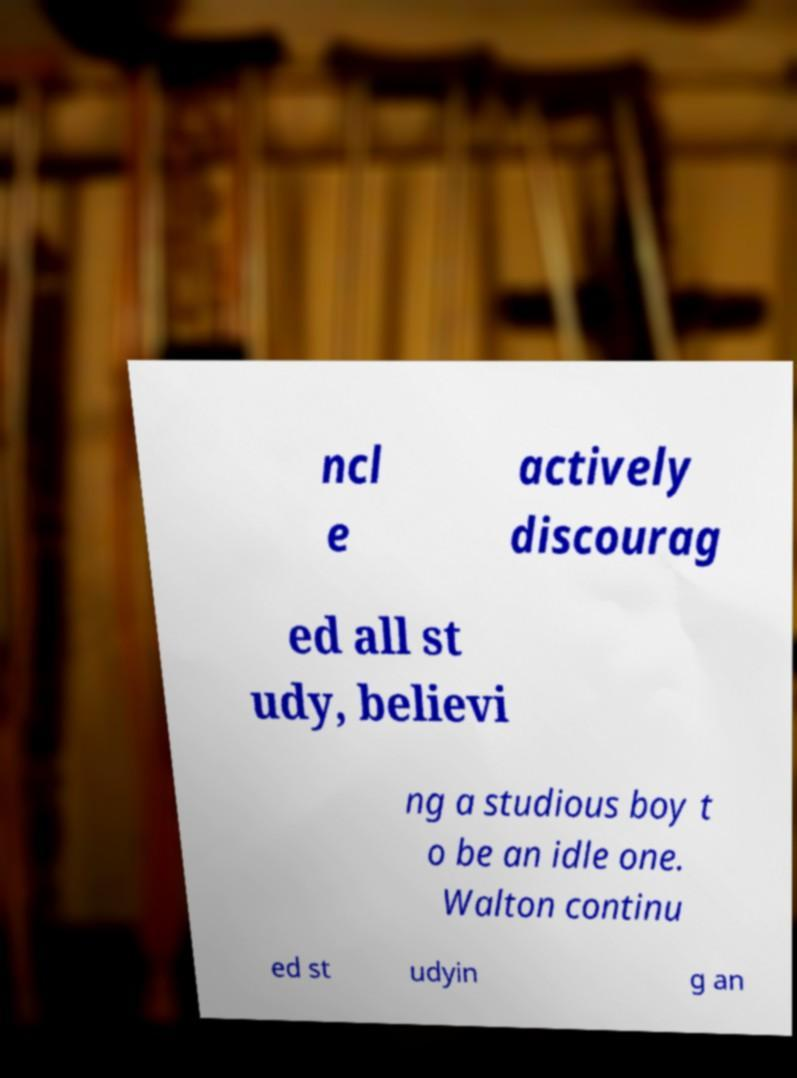What messages or text are displayed in this image? I need them in a readable, typed format. ncl e actively discourag ed all st udy, believi ng a studious boy t o be an idle one. Walton continu ed st udyin g an 